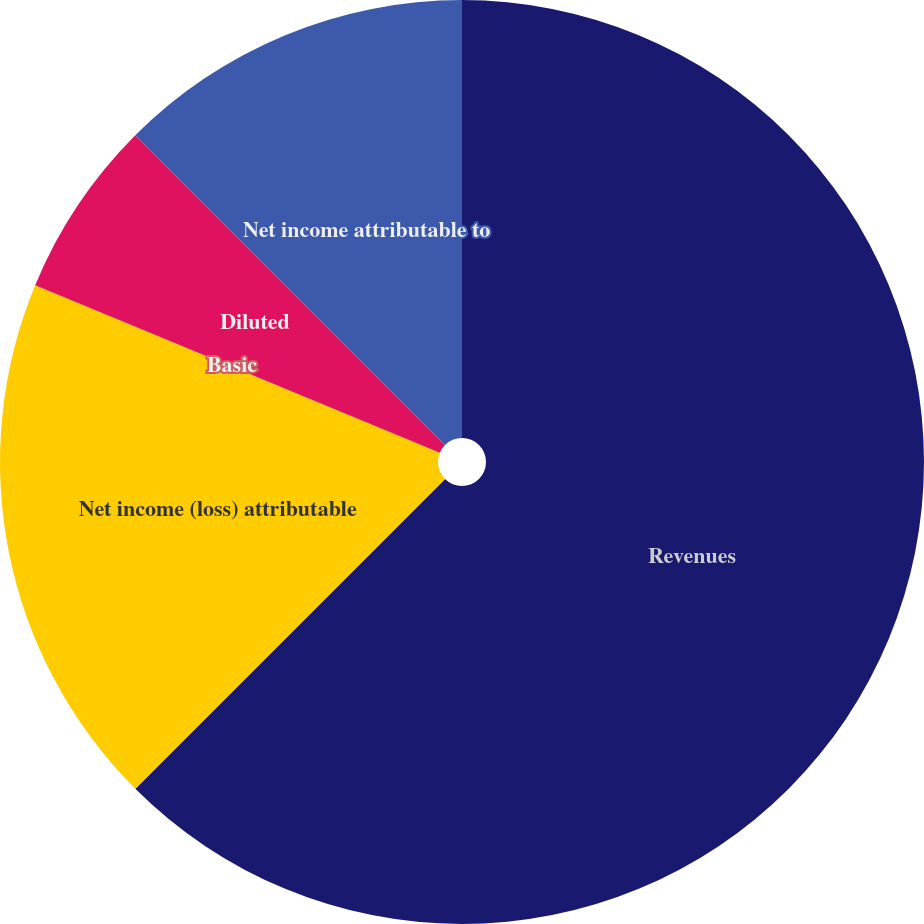<chart> <loc_0><loc_0><loc_500><loc_500><pie_chart><fcel>Revenues<fcel>Net income (loss) attributable<fcel>Basic<fcel>Diluted<fcel>Net income attributable to<nl><fcel>62.5%<fcel>18.75%<fcel>0.0%<fcel>6.25%<fcel>12.5%<nl></chart> 